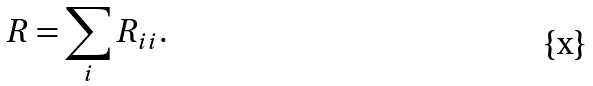<formula> <loc_0><loc_0><loc_500><loc_500>R = \sum _ { i } R _ { i i } .</formula> 